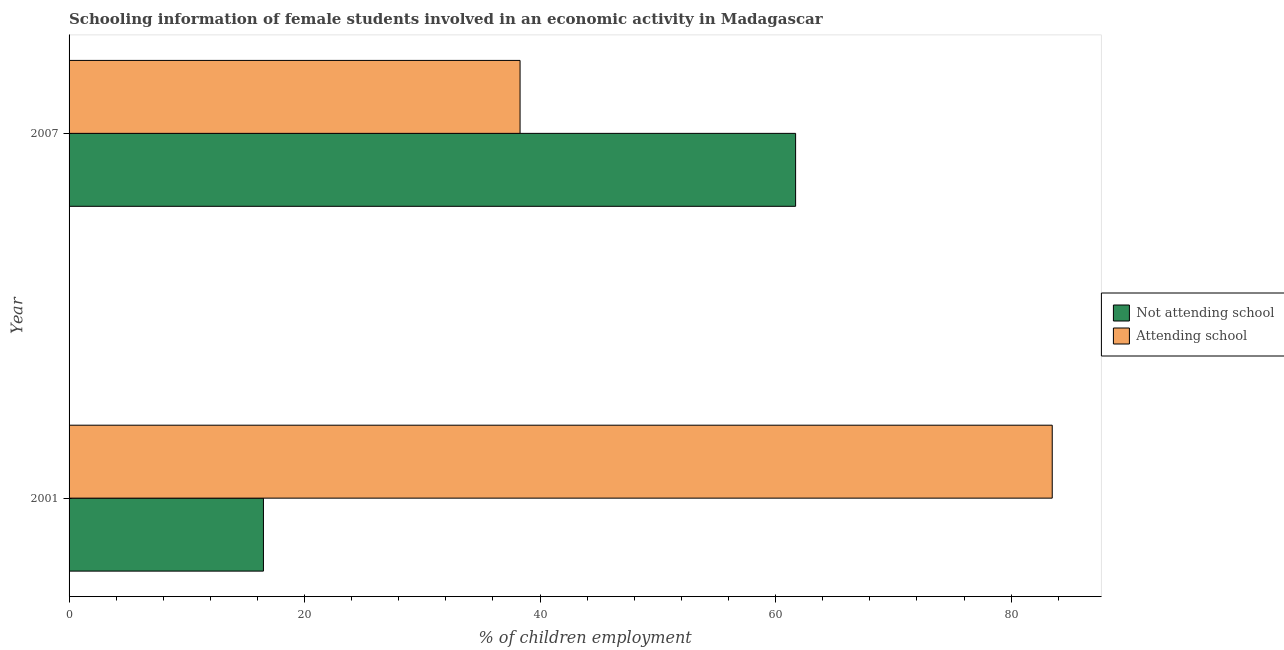How many different coloured bars are there?
Keep it short and to the point. 2. Are the number of bars per tick equal to the number of legend labels?
Your response must be concise. Yes. How many bars are there on the 2nd tick from the top?
Offer a very short reply. 2. What is the label of the 1st group of bars from the top?
Keep it short and to the point. 2007. In how many cases, is the number of bars for a given year not equal to the number of legend labels?
Offer a terse response. 0. What is the percentage of employed females who are not attending school in 2001?
Your answer should be very brief. 16.51. Across all years, what is the maximum percentage of employed females who are not attending school?
Your answer should be compact. 61.7. Across all years, what is the minimum percentage of employed females who are not attending school?
Your answer should be very brief. 16.51. What is the total percentage of employed females who are attending school in the graph?
Make the answer very short. 121.79. What is the difference between the percentage of employed females who are not attending school in 2001 and that in 2007?
Your response must be concise. -45.19. What is the difference between the percentage of employed females who are attending school in 2001 and the percentage of employed females who are not attending school in 2007?
Your response must be concise. 21.79. What is the average percentage of employed females who are not attending school per year?
Ensure brevity in your answer.  39.1. In the year 2001, what is the difference between the percentage of employed females who are attending school and percentage of employed females who are not attending school?
Your response must be concise. 66.99. In how many years, is the percentage of employed females who are attending school greater than 20 %?
Provide a succinct answer. 2. What is the ratio of the percentage of employed females who are attending school in 2001 to that in 2007?
Your answer should be very brief. 2.18. Is the percentage of employed females who are not attending school in 2001 less than that in 2007?
Make the answer very short. Yes. What does the 1st bar from the top in 2007 represents?
Your answer should be compact. Attending school. What does the 1st bar from the bottom in 2007 represents?
Provide a succinct answer. Not attending school. How many bars are there?
Offer a very short reply. 4. How many years are there in the graph?
Ensure brevity in your answer.  2. What is the difference between two consecutive major ticks on the X-axis?
Ensure brevity in your answer.  20. Are the values on the major ticks of X-axis written in scientific E-notation?
Your answer should be very brief. No. Does the graph contain any zero values?
Offer a very short reply. No. Does the graph contain grids?
Ensure brevity in your answer.  No. Where does the legend appear in the graph?
Give a very brief answer. Center right. How many legend labels are there?
Make the answer very short. 2. What is the title of the graph?
Ensure brevity in your answer.  Schooling information of female students involved in an economic activity in Madagascar. Does "Methane emissions" appear as one of the legend labels in the graph?
Provide a short and direct response. No. What is the label or title of the X-axis?
Offer a terse response. % of children employment. What is the label or title of the Y-axis?
Make the answer very short. Year. What is the % of children employment in Not attending school in 2001?
Offer a very short reply. 16.51. What is the % of children employment of Attending school in 2001?
Offer a terse response. 83.49. What is the % of children employment in Not attending school in 2007?
Provide a short and direct response. 61.7. What is the % of children employment in Attending school in 2007?
Keep it short and to the point. 38.3. Across all years, what is the maximum % of children employment in Not attending school?
Your answer should be very brief. 61.7. Across all years, what is the maximum % of children employment in Attending school?
Your response must be concise. 83.49. Across all years, what is the minimum % of children employment in Not attending school?
Ensure brevity in your answer.  16.51. Across all years, what is the minimum % of children employment of Attending school?
Ensure brevity in your answer.  38.3. What is the total % of children employment of Not attending school in the graph?
Your answer should be very brief. 78.21. What is the total % of children employment in Attending school in the graph?
Your answer should be very brief. 121.79. What is the difference between the % of children employment in Not attending school in 2001 and that in 2007?
Offer a very short reply. -45.19. What is the difference between the % of children employment of Attending school in 2001 and that in 2007?
Offer a terse response. 45.19. What is the difference between the % of children employment of Not attending school in 2001 and the % of children employment of Attending school in 2007?
Provide a succinct answer. -21.79. What is the average % of children employment of Not attending school per year?
Offer a terse response. 39.1. What is the average % of children employment in Attending school per year?
Provide a short and direct response. 60.9. In the year 2001, what is the difference between the % of children employment in Not attending school and % of children employment in Attending school?
Offer a very short reply. -66.99. In the year 2007, what is the difference between the % of children employment of Not attending school and % of children employment of Attending school?
Provide a short and direct response. 23.4. What is the ratio of the % of children employment in Not attending school in 2001 to that in 2007?
Keep it short and to the point. 0.27. What is the ratio of the % of children employment in Attending school in 2001 to that in 2007?
Keep it short and to the point. 2.18. What is the difference between the highest and the second highest % of children employment in Not attending school?
Provide a succinct answer. 45.19. What is the difference between the highest and the second highest % of children employment of Attending school?
Provide a succinct answer. 45.19. What is the difference between the highest and the lowest % of children employment of Not attending school?
Offer a very short reply. 45.19. What is the difference between the highest and the lowest % of children employment of Attending school?
Make the answer very short. 45.19. 